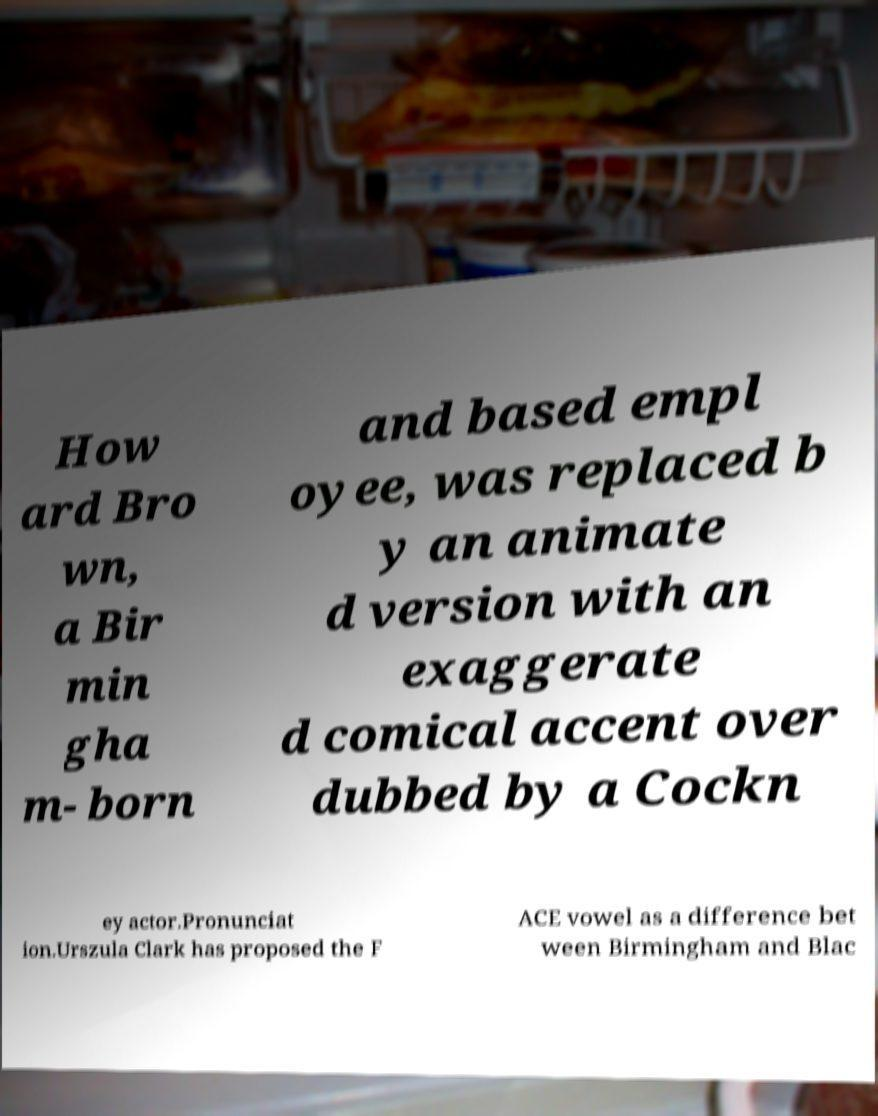Please read and relay the text visible in this image. What does it say? How ard Bro wn, a Bir min gha m- born and based empl oyee, was replaced b y an animate d version with an exaggerate d comical accent over dubbed by a Cockn ey actor.Pronunciat ion.Urszula Clark has proposed the F ACE vowel as a difference bet ween Birmingham and Blac 